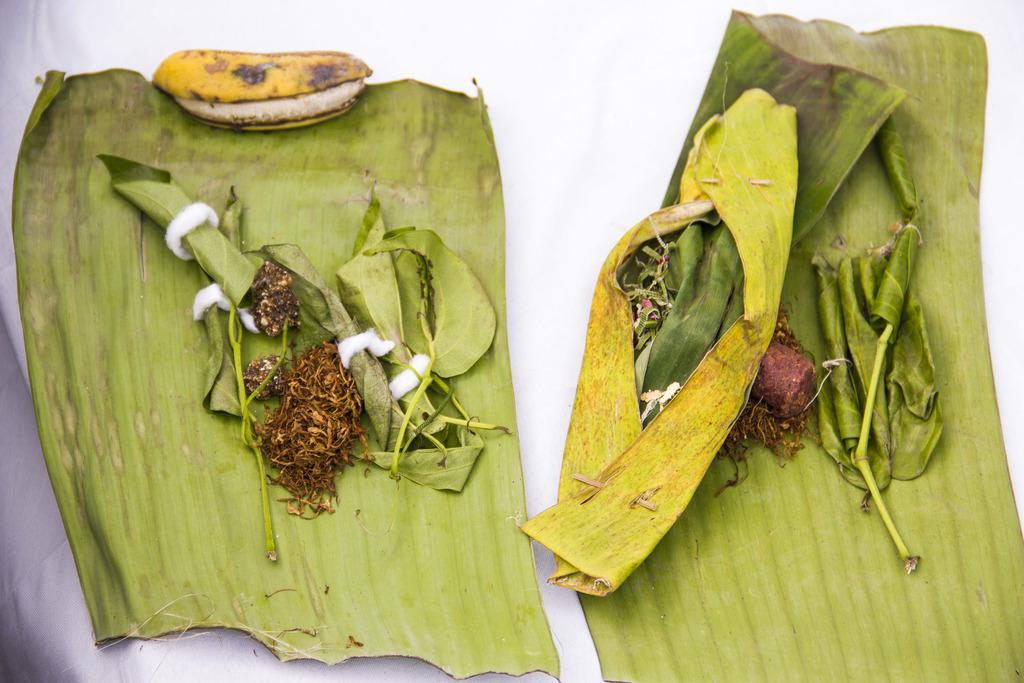What type of fruit is in the image? There is a banana in the image. What other natural elements are present in the image? There are leaves in the image. On what surface are the banana and leaves placed? The banana and leaves are placed on a white cloth. What type of grain is being processed in the middle of the image? There is no grain or processing activity present in the image; it features a banana and leaves placed on a white cloth. 